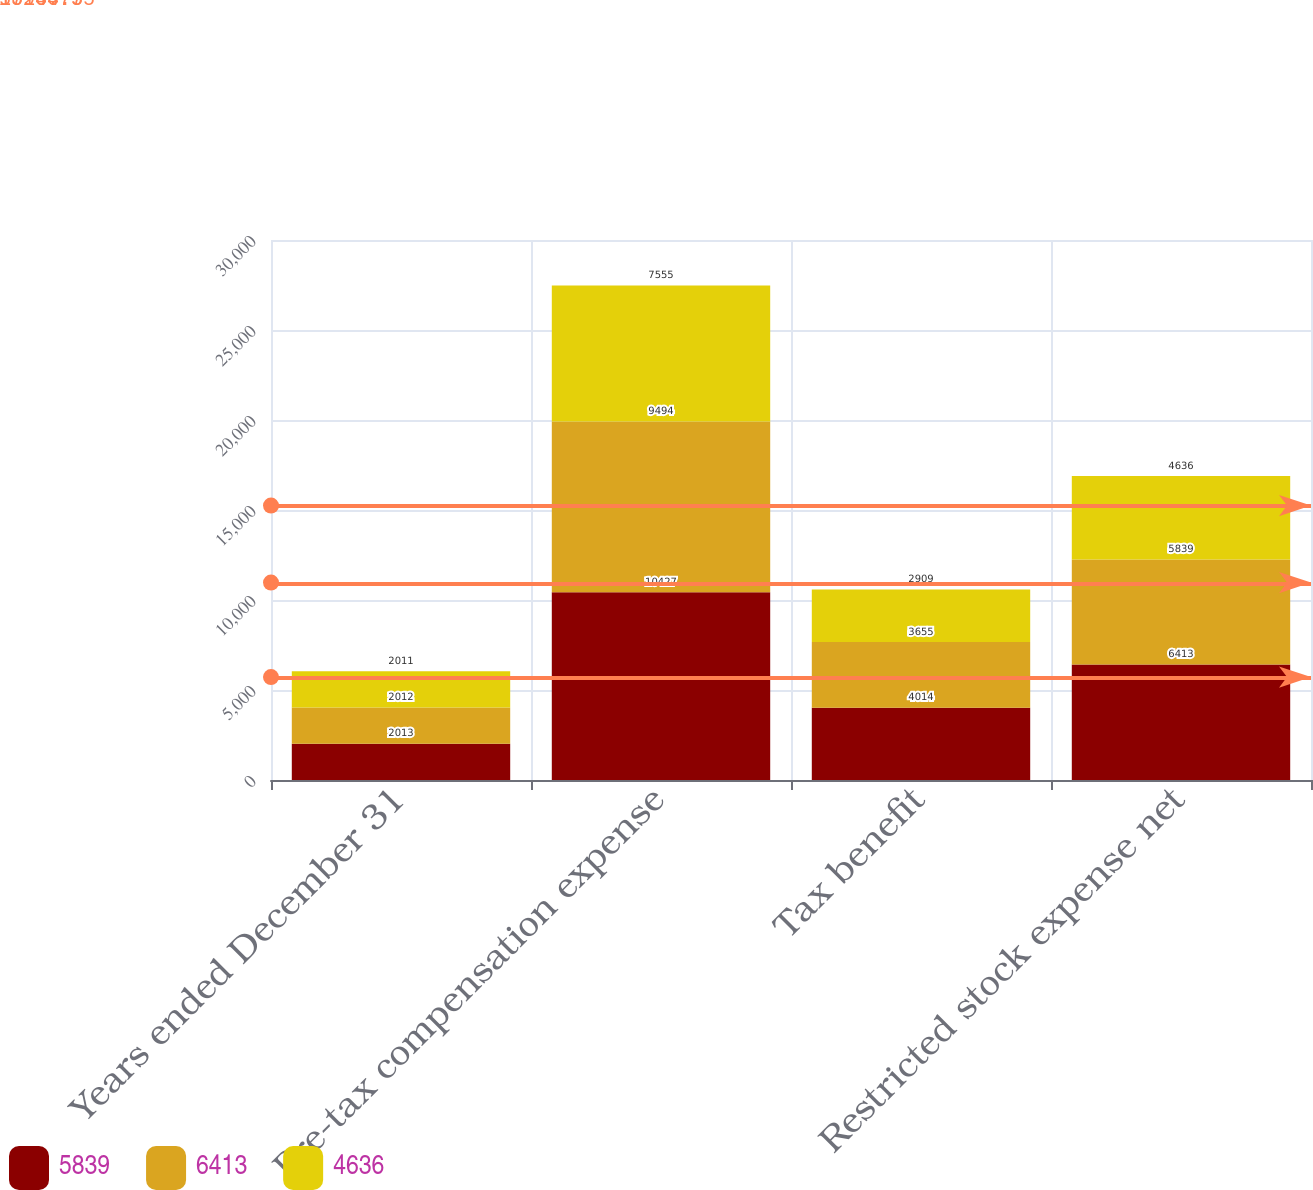Convert chart. <chart><loc_0><loc_0><loc_500><loc_500><stacked_bar_chart><ecel><fcel>Years ended December 31<fcel>Pre-tax compensation expense<fcel>Tax benefit<fcel>Restricted stock expense net<nl><fcel>5839<fcel>2013<fcel>10427<fcel>4014<fcel>6413<nl><fcel>6413<fcel>2012<fcel>9494<fcel>3655<fcel>5839<nl><fcel>4636<fcel>2011<fcel>7555<fcel>2909<fcel>4636<nl></chart> 